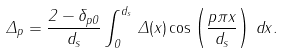<formula> <loc_0><loc_0><loc_500><loc_500>\Delta _ { p } = \frac { 2 - \delta _ { p 0 } } { d _ { s } } \int _ { 0 } ^ { d _ { s } } \, \Delta ( x ) \cos \left ( \frac { p \pi x } { d _ { s } } \right ) \, d x .</formula> 